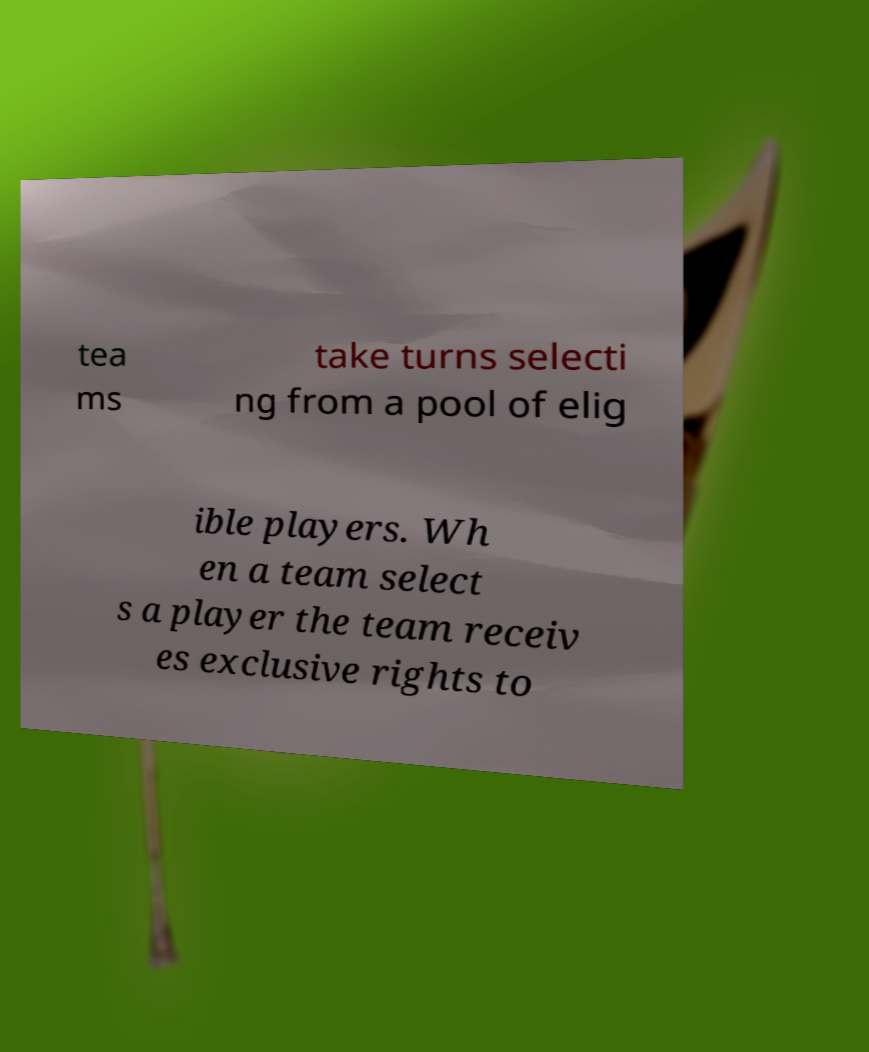Could you assist in decoding the text presented in this image and type it out clearly? tea ms take turns selecti ng from a pool of elig ible players. Wh en a team select s a player the team receiv es exclusive rights to 